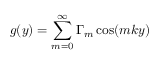Convert formula to latex. <formula><loc_0><loc_0><loc_500><loc_500>g ( y ) = \sum _ { m = 0 } ^ { \infty } \Gamma _ { m } \cos ( m k y )</formula> 